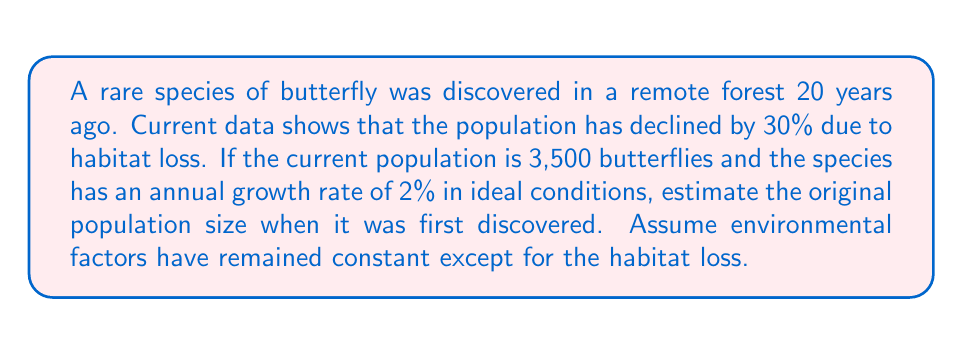What is the answer to this math problem? Let's approach this step-by-step:

1) Let $P_0$ be the original population and $P_t$ be the current population after $t$ years.

2) We know that $P_t = 3,500$ and $t = 20$ years.

3) The population growth can be modeled using the compound interest formula:
   $P_t = P_0 \cdot (1 + r)^t$
   Where $r$ is the annual growth rate (2% = 0.02)

4) However, we also need to account for the 30% decline due to habitat loss. Let's call this factor $d = 0.7$ (as 70% of the population remained).

5) Our modified equation becomes:
   $P_t = P_0 \cdot (1 + r)^t \cdot d$

6) Substituting the known values:
   $3,500 = P_0 \cdot (1 + 0.02)^{20} \cdot 0.7$

7) Solving for $P_0$:
   $P_0 = \frac{3,500}{(1.02)^{20} \cdot 0.7}$

8) Calculate $(1.02)^{20}$ using a calculator: $(1.02)^{20} \approx 1.4859$

9) Now we can solve:
   $P_0 = \frac{3,500}{1.4859 \cdot 0.7} \approx 3,365$

10) Rounding to the nearest whole number (as we can't have fractional butterflies), we get 3,365 butterflies.
Answer: 3,365 butterflies 